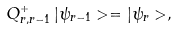<formula> <loc_0><loc_0><loc_500><loc_500>Q _ { r , r - 1 } ^ { + } \, | \psi _ { r - 1 } > = | \psi _ { r } > ,</formula> 